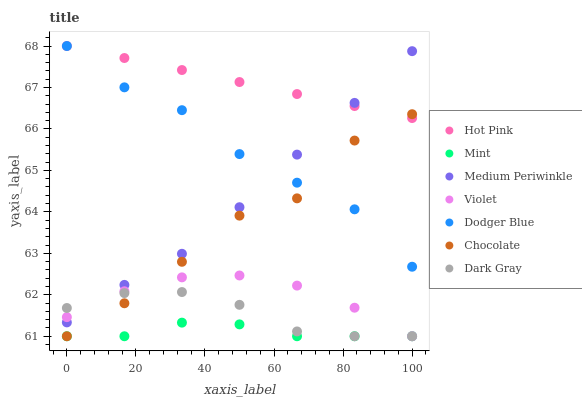Does Mint have the minimum area under the curve?
Answer yes or no. Yes. Does Hot Pink have the maximum area under the curve?
Answer yes or no. Yes. Does Medium Periwinkle have the minimum area under the curve?
Answer yes or no. No. Does Medium Periwinkle have the maximum area under the curve?
Answer yes or no. No. Is Hot Pink the smoothest?
Answer yes or no. Yes. Is Chocolate the roughest?
Answer yes or no. Yes. Is Medium Periwinkle the smoothest?
Answer yes or no. No. Is Medium Periwinkle the roughest?
Answer yes or no. No. Does Chocolate have the lowest value?
Answer yes or no. Yes. Does Medium Periwinkle have the lowest value?
Answer yes or no. No. Does Dodger Blue have the highest value?
Answer yes or no. Yes. Does Medium Periwinkle have the highest value?
Answer yes or no. No. Is Mint less than Hot Pink?
Answer yes or no. Yes. Is Medium Periwinkle greater than Mint?
Answer yes or no. Yes. Does Hot Pink intersect Dodger Blue?
Answer yes or no. Yes. Is Hot Pink less than Dodger Blue?
Answer yes or no. No. Is Hot Pink greater than Dodger Blue?
Answer yes or no. No. Does Mint intersect Hot Pink?
Answer yes or no. No. 